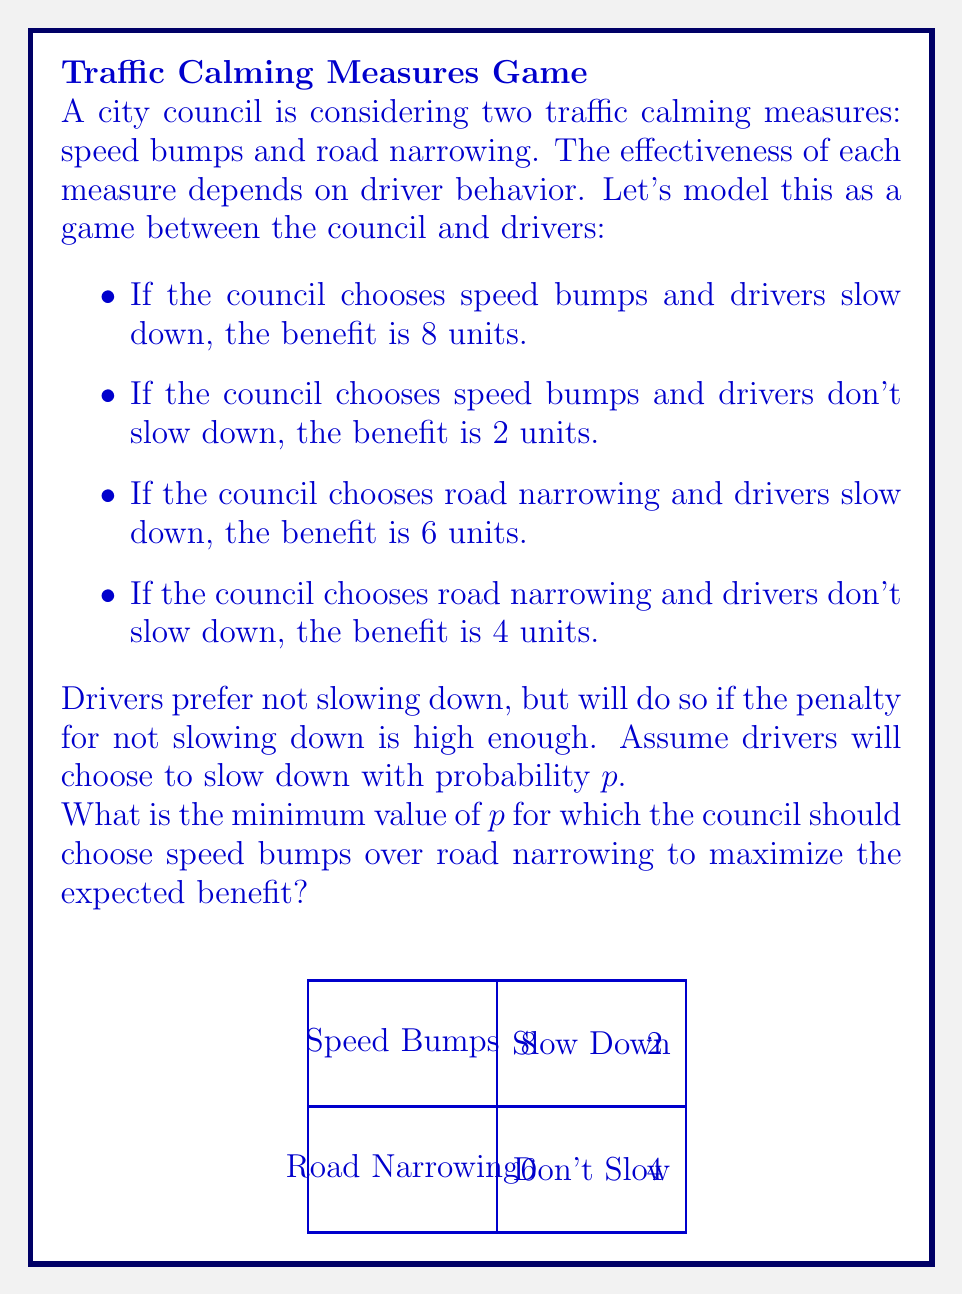Give your solution to this math problem. Let's approach this step-by-step using game theory principles:

1) First, we need to calculate the expected benefit for each strategy:

   For speed bumps: $E(\text{Speed Bumps}) = 8p + 2(1-p) = 6p + 2$
   For road narrowing: $E(\text{Road Narrowing}) = 6p + 4(1-p) = 2p + 4$

2) The council should choose speed bumps when its expected benefit is greater than or equal to that of road narrowing:

   $6p + 2 \geq 2p + 4$

3) Let's solve this inequality:

   $6p + 2 \geq 2p + 4$
   $4p \geq 2$
   $p \geq \frac{1}{2}$

4) Therefore, the minimum value of $p$ for which the council should choose speed bumps is $\frac{1}{2}$ or 0.5.

This means that if drivers are expected to slow down with a probability greater than or equal to 50%, the council should choose speed bumps to maximize the expected benefit.
Answer: $\frac{1}{2}$ 